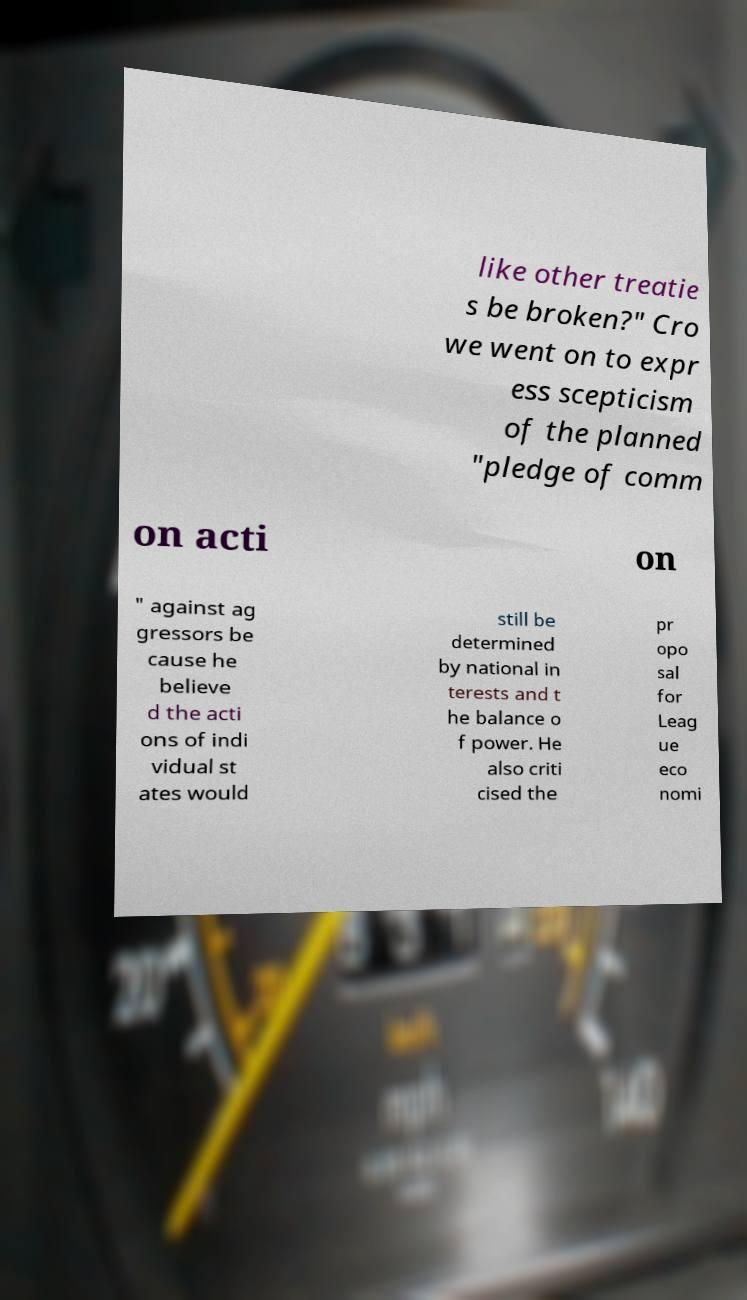Can you accurately transcribe the text from the provided image for me? like other treatie s be broken?" Cro we went on to expr ess scepticism of the planned "pledge of comm on acti on " against ag gressors be cause he believe d the acti ons of indi vidual st ates would still be determined by national in terests and t he balance o f power. He also criti cised the pr opo sal for Leag ue eco nomi 